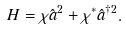Convert formula to latex. <formula><loc_0><loc_0><loc_500><loc_500>H = \chi \hat { a } ^ { 2 } + \chi ^ { * } \hat { a } ^ { \dagger 2 } .</formula> 